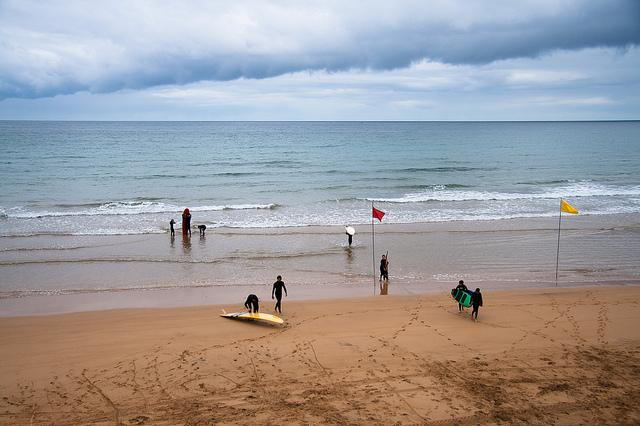What does the red flag mean?

Choices:
A) hot weather
B) swimming prohibited
C) victory
D) tsunami swimming prohibited 